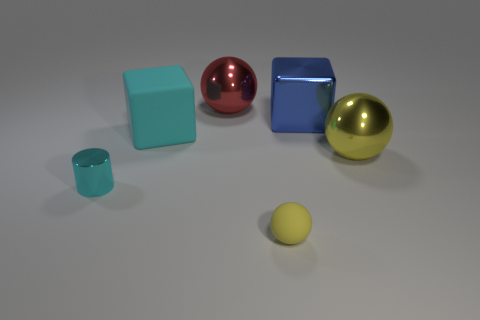Does the matte cube have the same color as the tiny object that is to the left of the tiny yellow rubber thing?
Provide a short and direct response. Yes. What number of other things are there of the same color as the big matte thing?
Make the answer very short. 1. There is a matte object that is in front of the shiny cylinder; does it have the same size as the metal object that is in front of the yellow metallic ball?
Your response must be concise. Yes. There is a large metallic ball in front of the red shiny ball; what color is it?
Ensure brevity in your answer.  Yellow. Are there fewer small cyan things right of the matte sphere than yellow metallic spheres?
Keep it short and to the point. Yes. Is the big blue object made of the same material as the cyan block?
Give a very brief answer. No. There is a rubber thing that is the same shape as the large yellow metal object; what size is it?
Give a very brief answer. Small. How many things are either matte objects in front of the big cyan matte cube or metal objects that are on the left side of the small yellow ball?
Make the answer very short. 3. Are there fewer metal cubes than tiny cyan rubber cylinders?
Give a very brief answer. No. Is the size of the shiny cylinder the same as the rubber thing that is on the right side of the large cyan matte object?
Your answer should be compact. Yes. 